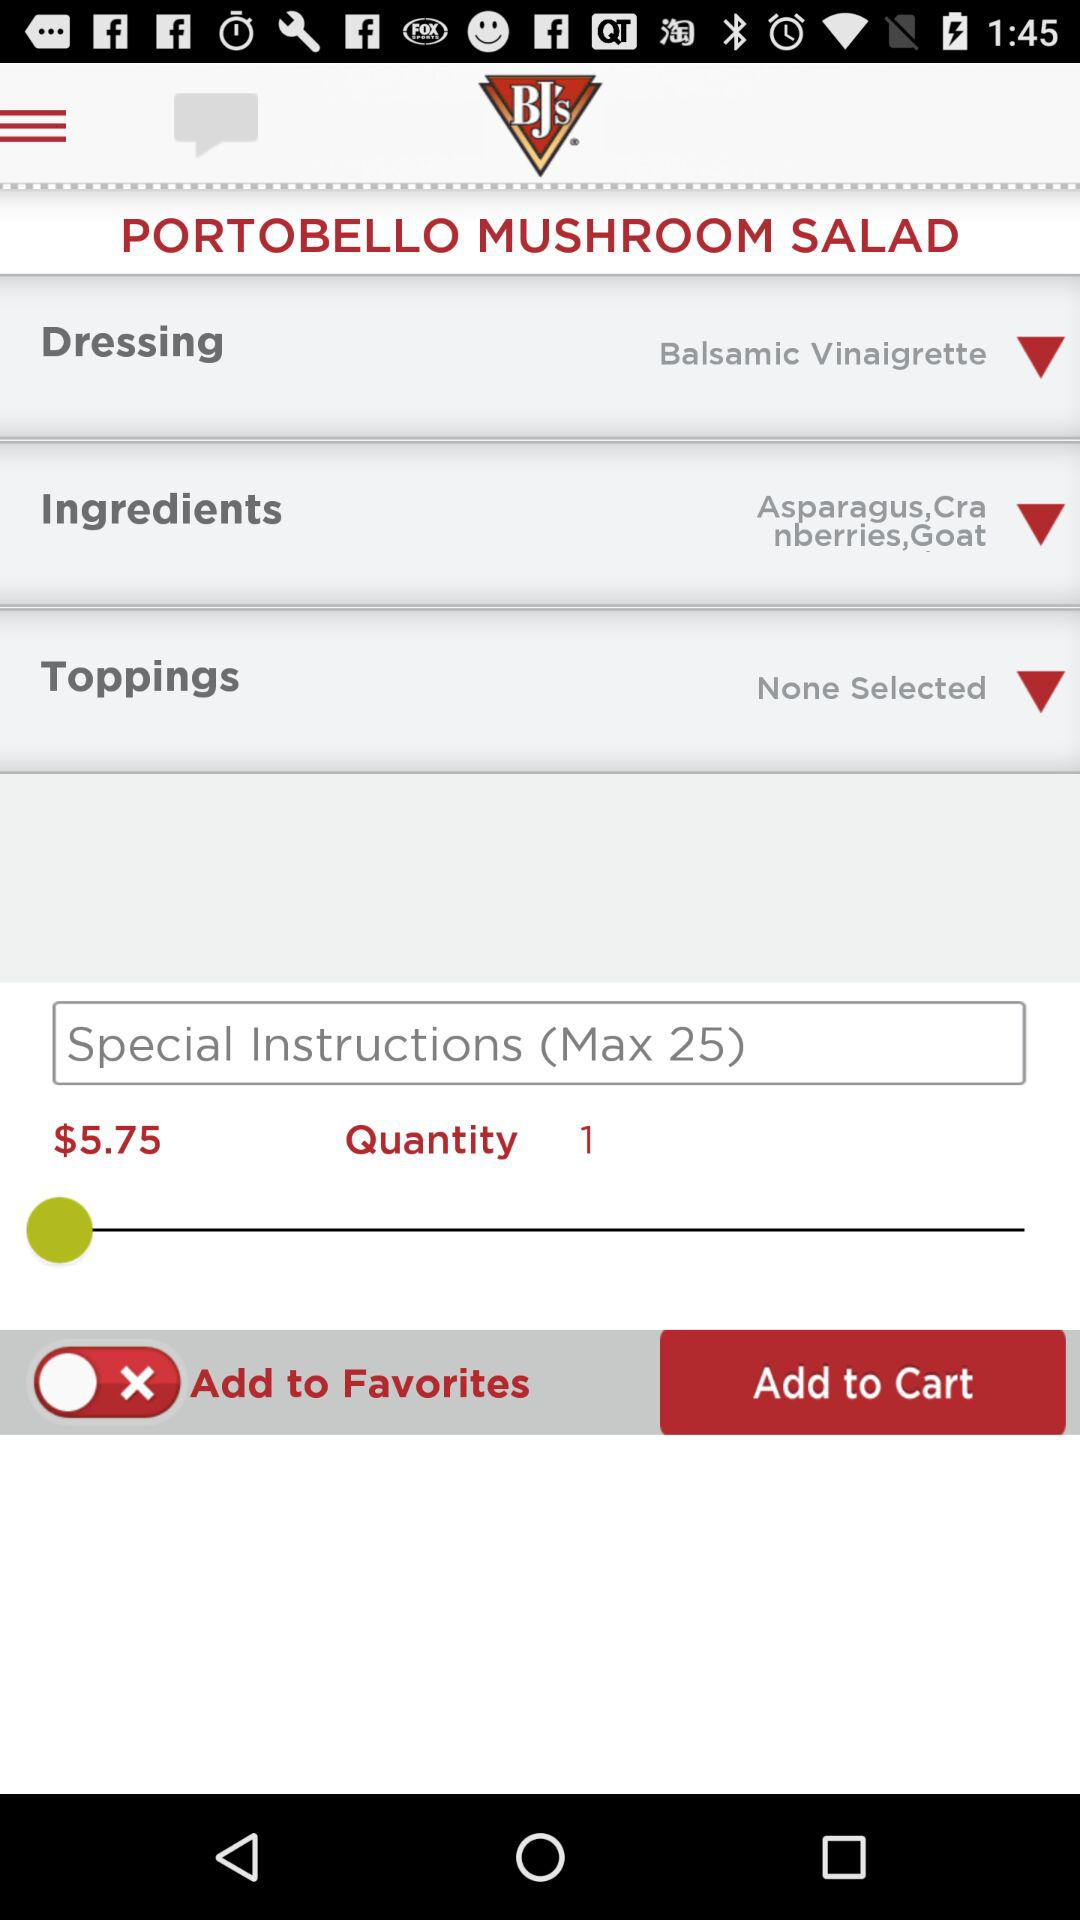What is the selected quantity? The selected quantity is 1. 